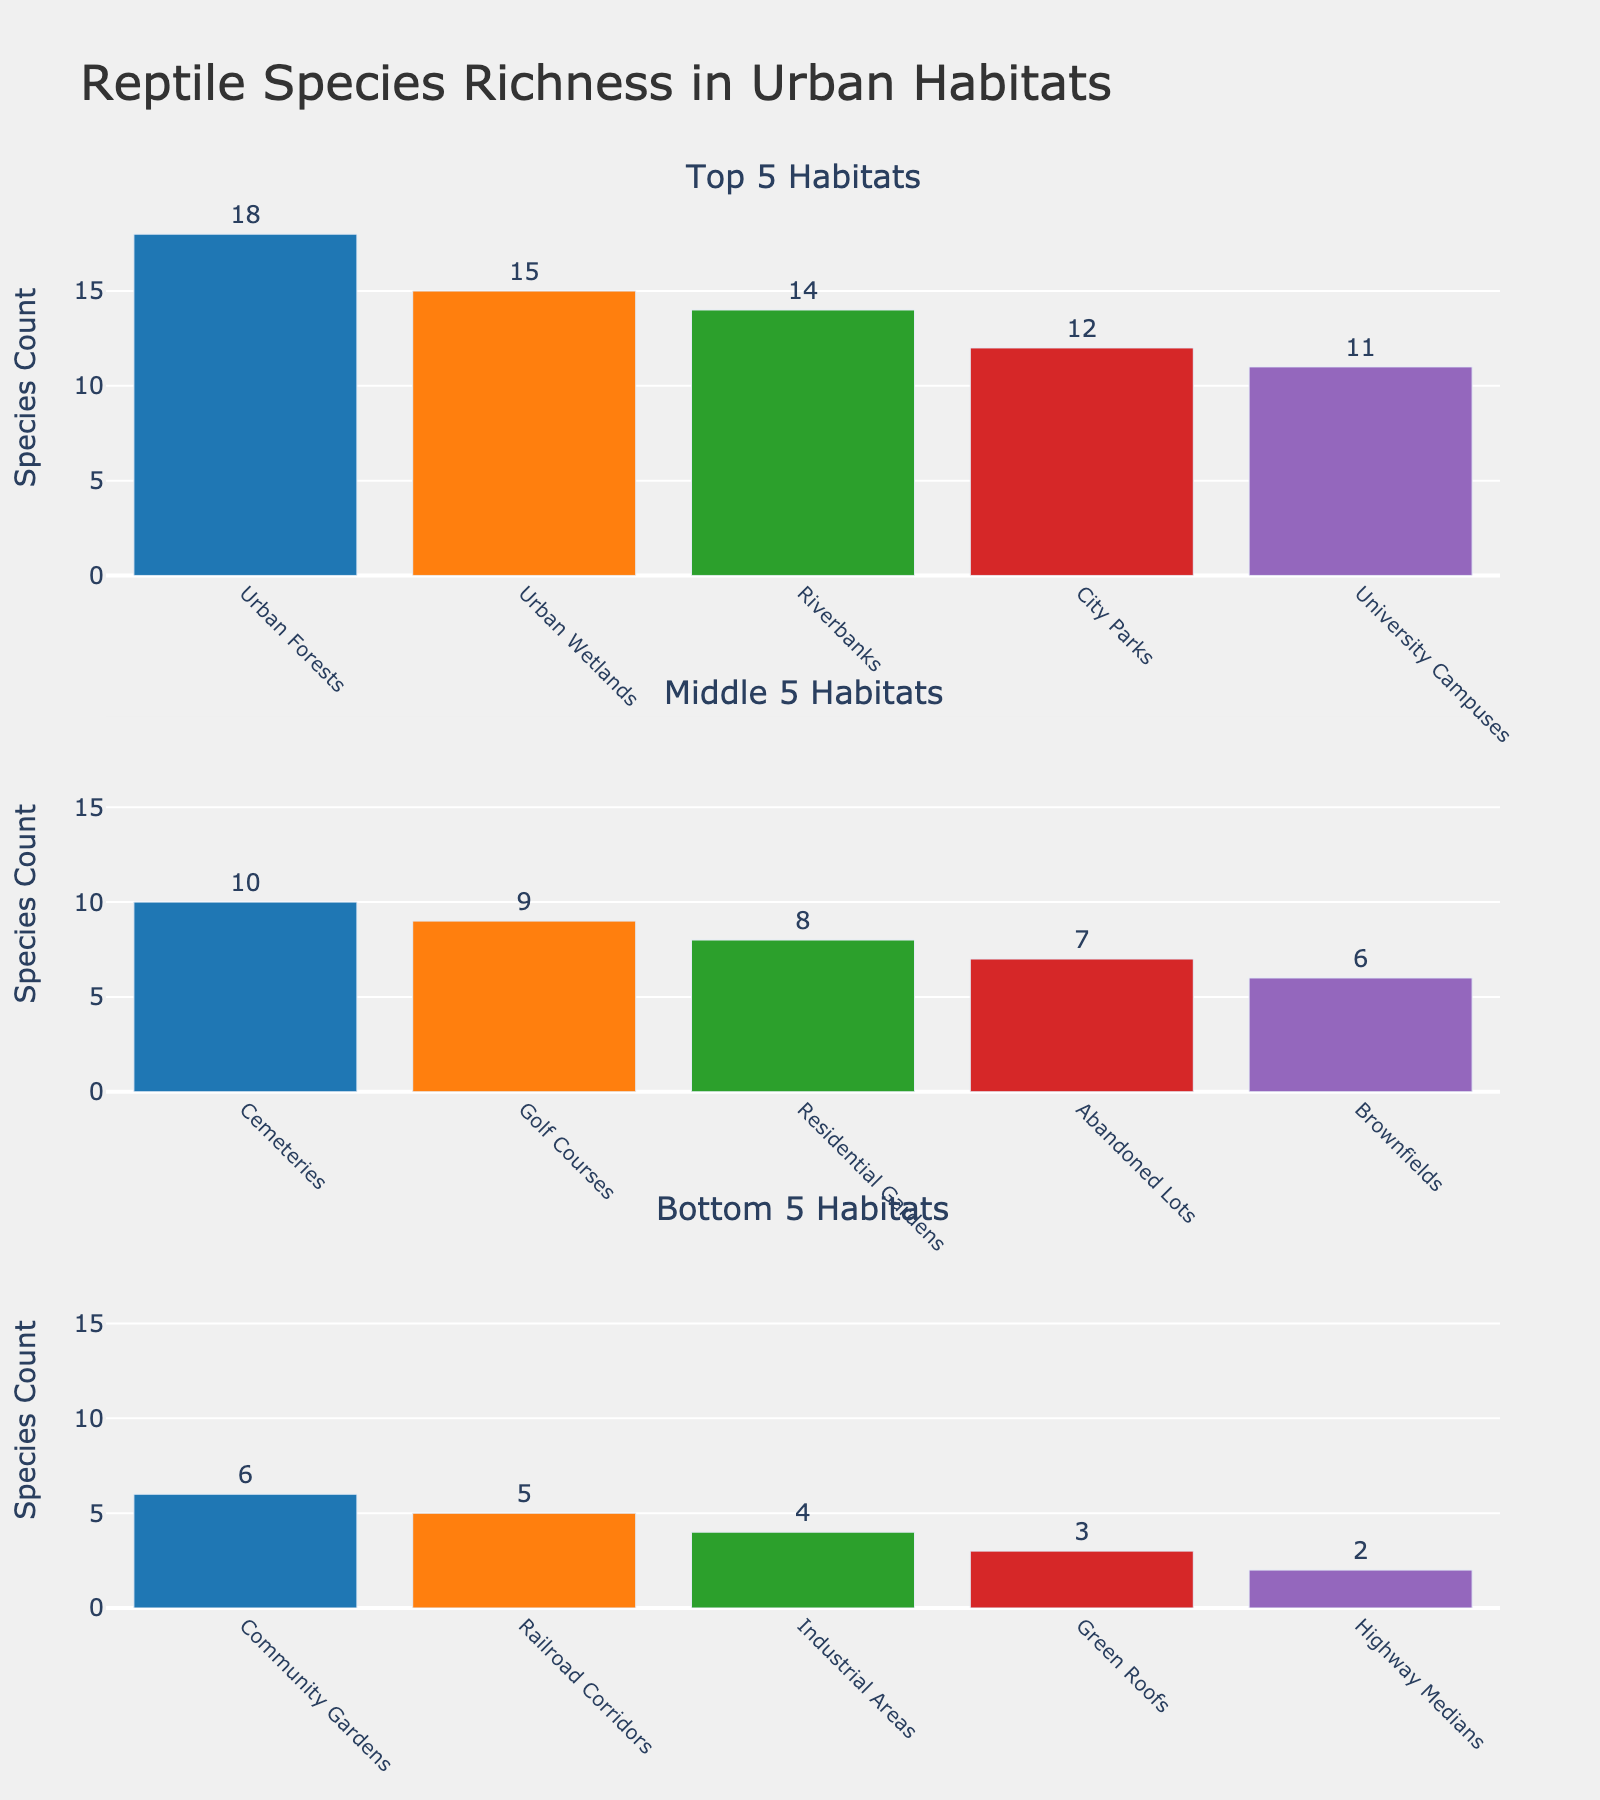What's the title of the chart? The title of the chart is typically located at the top center and aggregated from the plot layout. In this case, it is directly listed.
Answer: Reptile Species Richness in Urban Habitats How many habitat types are included in the top 5 habitats? The "Top 5 Habitats" subplot title indicates that the histogram for this section includes the first five habitat types based on their species count.
Answer: 5 Which habitat type has the highest species richness? The most enriched is observed by identifying the highest bar height in the top 5 habitats subplot.
Answer: Urban Forests What is the species count difference between "City Parks" and "Residential Gardens"? To determine this, find the bar heights for both habitats in the figure and compute the difference. "City Parks" has 12 species and "Residential Gardens" has 8 species.
Answer: 4 What is the combined species count of all the habitats in the "Bottom 5 Habitats" subplot? Sum the species counts for the five habitats listed in the bottom subplot. These are Green Roofs (3), Industrial Areas (4), Highway Medians (2), Railroad Corridors (5), and Brownfields (6). Total = 3 + 4 + 2 + 5 + 6.
Answer: 20 Which habitat type in the "Middle 5 Habitats" has the lowest species count? Within the middle 5 group, comparing the heights of the bars for the habitats: Cemeteries, Community Gardens, Golf Courses, City Parks, University Campuses, the shortest one is Community Gardens.
Answer: Community Gardens What is the average species count for the habitats in the "Top 5 Habitats" subplot? Sum the species counts of the five habitats (Urban Forests, Urban Wetlands, Riverbanks, City Parks, University Campuses) and divide by 5. (18 + 15 + 14 + 12 + 11) / 5.
Answer: 14 Which habitat in the middle 5 has the species count closest to the median? The median value of the middle 5 counts can be found by arranging them in order, then identifying the middle value. List the species counts (10, 9, 8, 7, 6), the median value is 8.
Answer: Residential Gardens How do species counts in "Industrial Areas" compare to "Railroad Corridors"? Compare their bar heights found in the bottom 5 subplot, where "Industrial Areas" has 4 and "Railroad Corridors" has 5.
Answer: Railroad Corridors has 1 more species Is the species count on "University Campuses" higher or lower than "City Parks"? Compare the bar heights for these two habitats listed in this plot; "University Campuses" has 11, while "City Parks" has 12.
Answer: Lower 